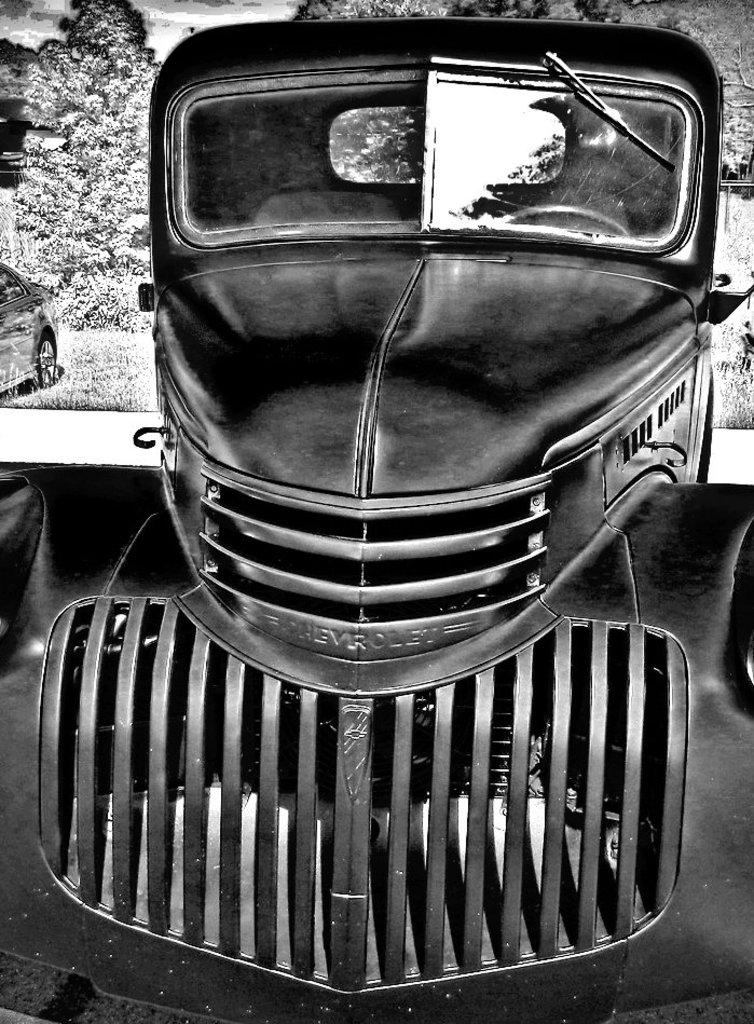What type of vehicles can be seen in the image? There are cars in the image. What can be seen in the distance behind the cars? There are trees in the background of the image. What color scheme is used in the image? The image is in black and white. What verse is being recited by the arm in the image? There is no arm or verse present in the image; it features cars and trees in a black and white color scheme. 